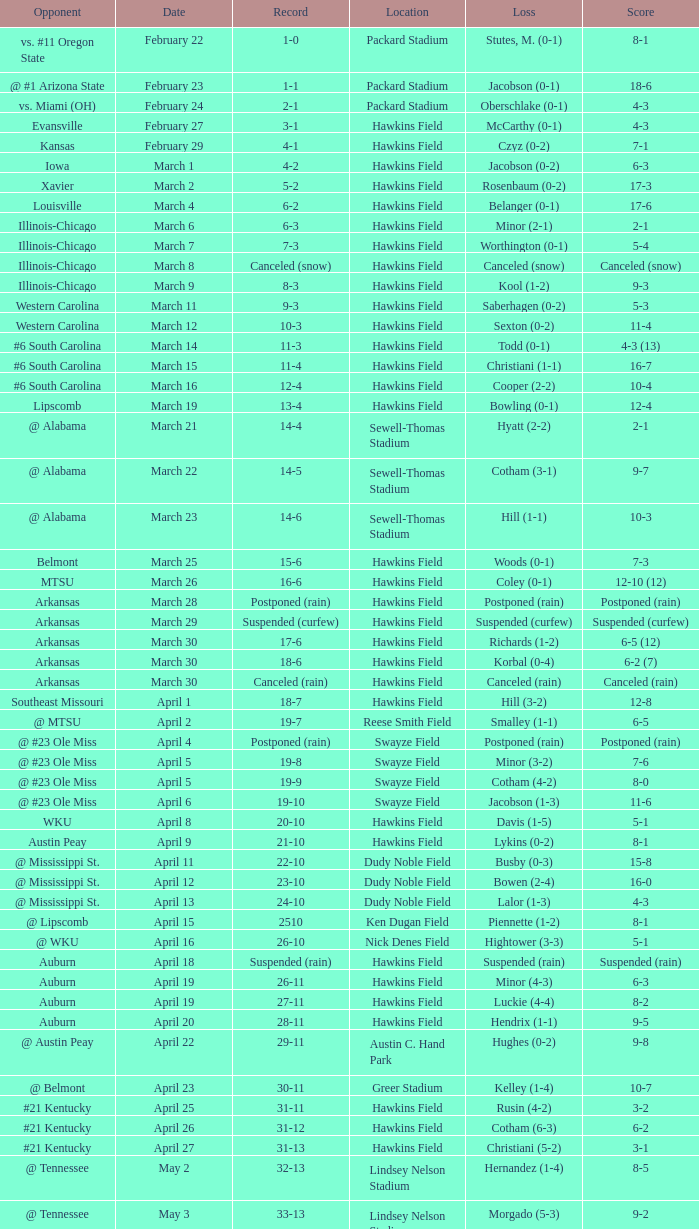What was the location of the game when the record was 12-4? Hawkins Field. 